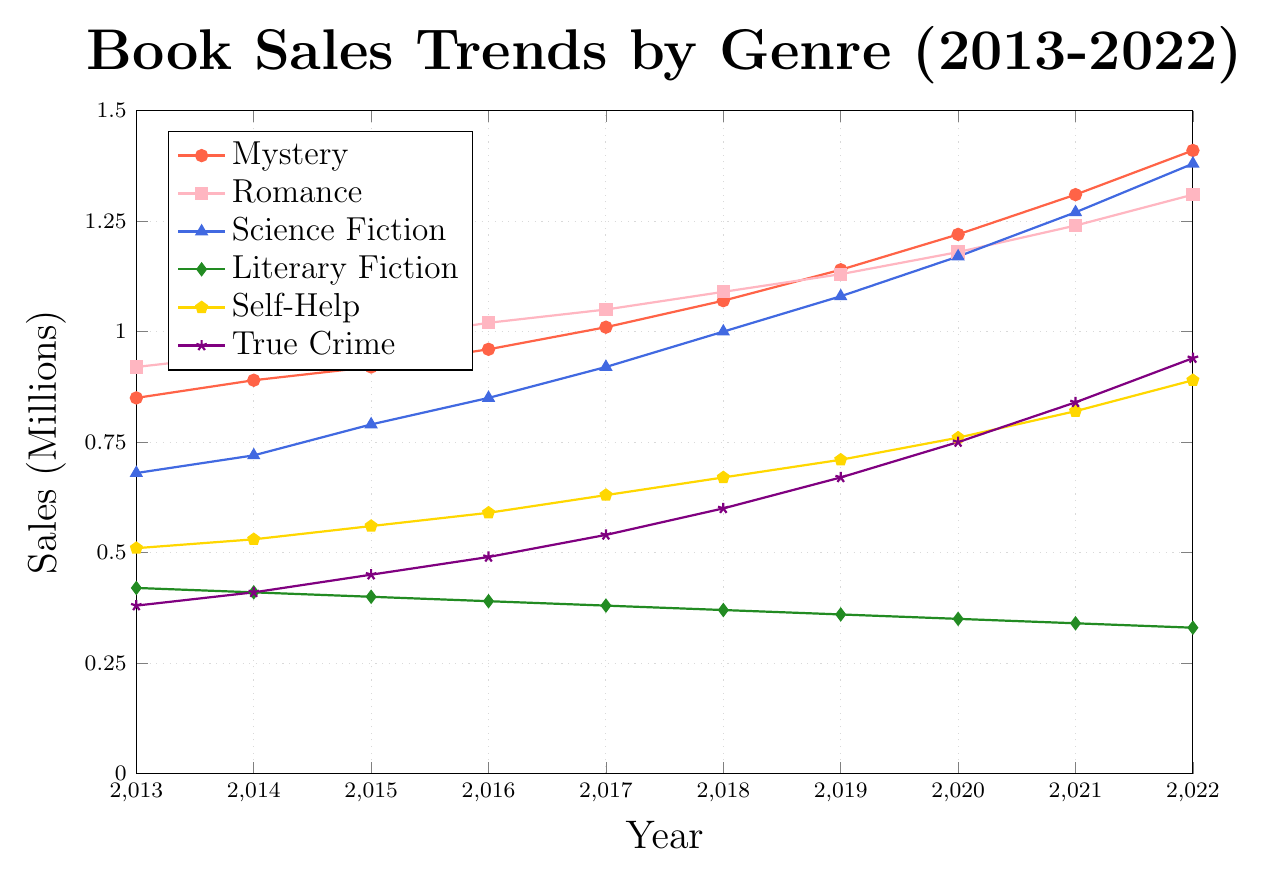Which genre had the highest total sales in 2022? By looking at the final points on each line, we can see that Mystery had the highest sales in 2022 with 1.41 million sales.
Answer: Mystery What was the sales difference between Romance and Science Fiction in 2017? In 2017, Romance had 1.05 million sales and Science Fiction had 0.92 million sales. The difference is 1.05 - 0.92 = 0.13 million.
Answer: 0.13 million What trend can be observed for Literary Fiction sales over the decade? Literary Fiction sales follow a declining trend from 0.42 million in 2013 to 0.33 million in 2022, decreasing almost consistently every year.
Answer: Declining In which year did True Crime and Self-Help sales first exceed 500,000 each? By examining the plot, True Crime sales exceeded 500,000 in 2017 and Self-Help sales exceeded 500,000 in 2017 as well.
Answer: 2017 What was the average sales of Mystery books from 2013 to 2022? Sum the sales from 2013 to 2022: 0.85 + 0.89 + 0.92 + 0.96 + 1.01 + 1.07 + 1.14 + 1.22 + 1.31 + 1.41 = 10.78 million. Average = 10.78 / 10 = 1.078 million.
Answer: 1.078 million Which genre grew the most in terms of sales from 2013 to 2022? Calculate the difference for each genre: 
- Mystery: 1.41 - 0.85 = 0.56 million
- Romance: 1.31 - 0.92 = 0.39 million
- Science Fiction: 1.38 - 0.68 = 0.70 million
- Literary Fiction: 0.33 - 0.42 = -0.09 million
- Self-Help: 0.89 - 0.51 = 0.38 million
- True Crime: 0.94 - 0.38 = 0.56 million. Science Fiction grew the most with an increase of 0.70 million.
Answer: Science Fiction What color is used to represent Self-Help genre in the chart? By referring to the visual attributes of the chart, Self-Help is represented in yellow.
Answer: Yellow How did the sales of Science Fiction compare to Mystery in 2020? In 2020, Science Fiction had 1.17 million sales and Mystery had 1.22 million sales, so Mystery had higher sales.
Answer: Mystery had higher sales Based on the chart, which genre showed the most consistent yearly sales increase could be considered steady growth? By examining the slopes of each line, Self-Help shows a steady increase without any significant fluctuations from 2013 to 2022.
Answer: Self-Help 